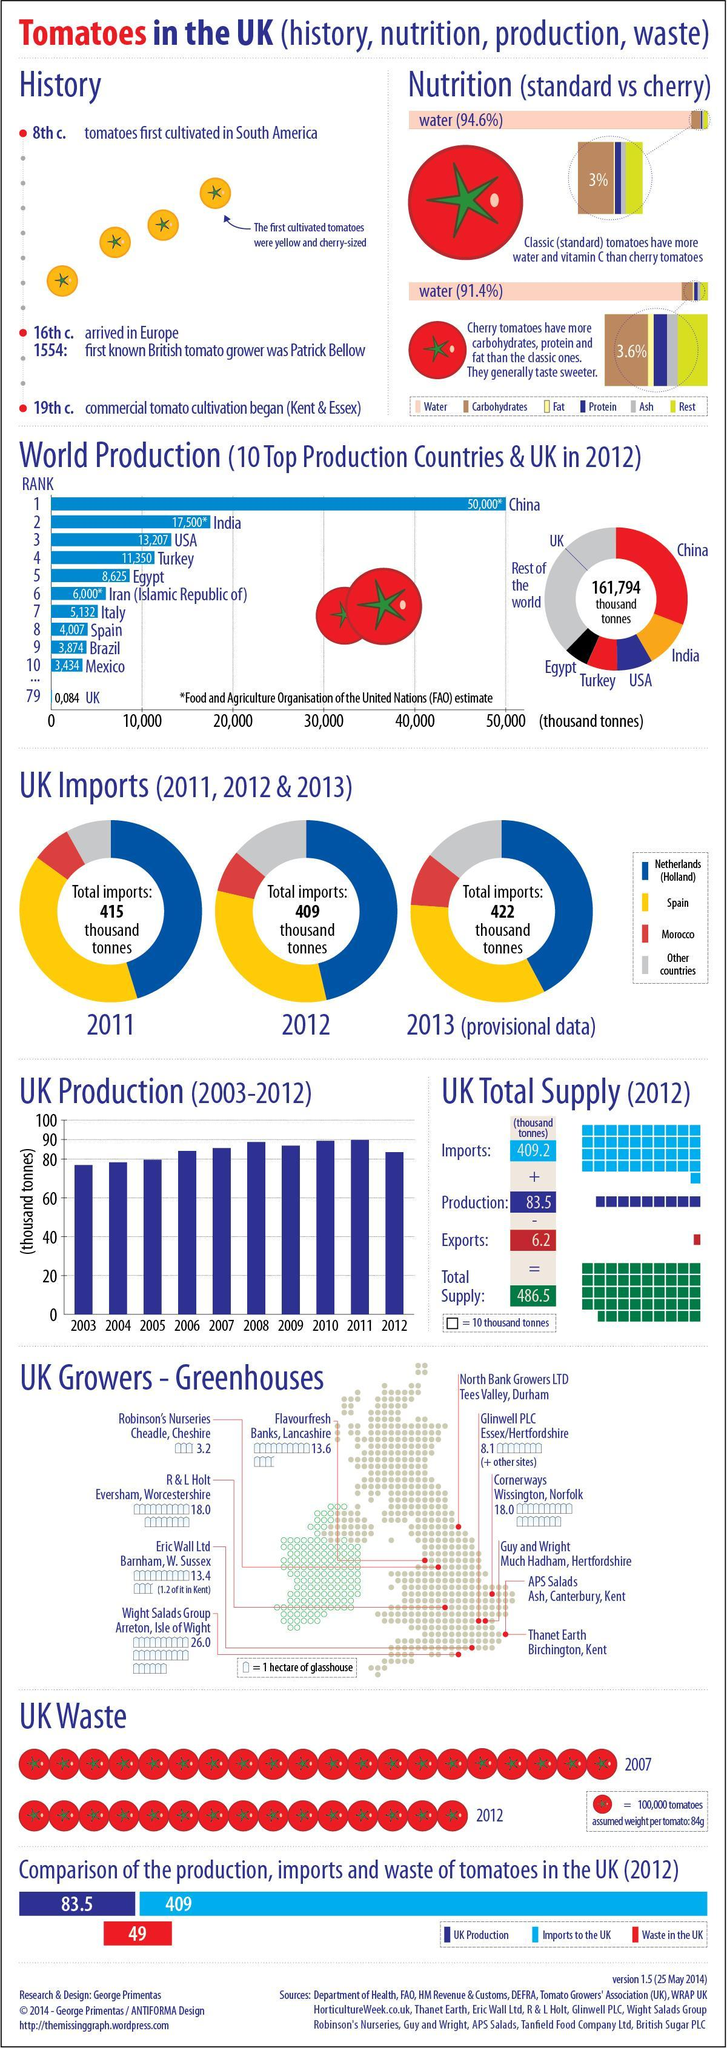How many thousand tonnes of tomatoes were produced in Italy according to the FAO of the United Nation estimate in 2012?
Answer the question with a short phrase. 5,132 What is the total imports of tomatoes (in thousand tonnes) in UK in 2011? 415 Which country is the largest producer of tomatoes as per the FAO of the United Nation estimate in 2012? China What is the percentage of water present in cherry tomatoes? 91.4% Which country is the second largest producer of tomatoes as per the FAO of the United Nation estimate in 2012? India What is the percentage of water present in classic tomatoes? (94.6%) Which type of tomatoes taste sweeter? cherry tomatoes How many thousand tonnes of tomatoes were imported to UK in 2012? 409 How many thousand tonnes of tomatoes were wasted in UK in 2012? 49 How many thousand tonnes of tomatoes were produced in USA according to the FAO of the United Nation estimate in 2012? 13,207 